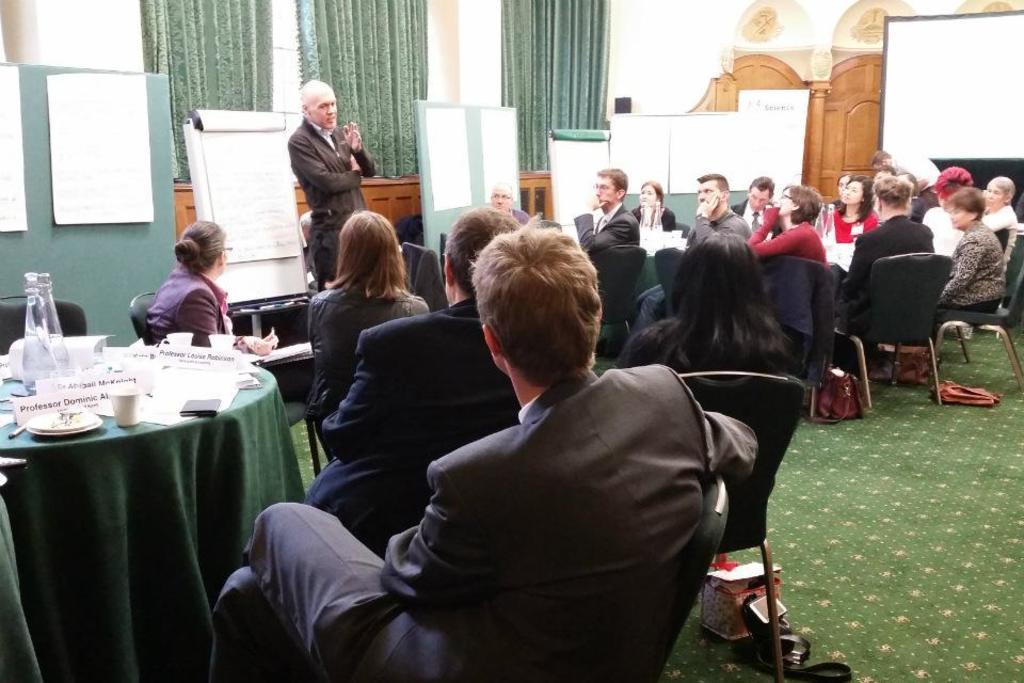Please provide a concise description of this image. This is a picture taken in a room, there are a group of people sitting on a chair in front of these people there is a table covered with a cloth on the table there are plates, spoons, name board, cup and a jar. Behind these people there is a board and a wall. 